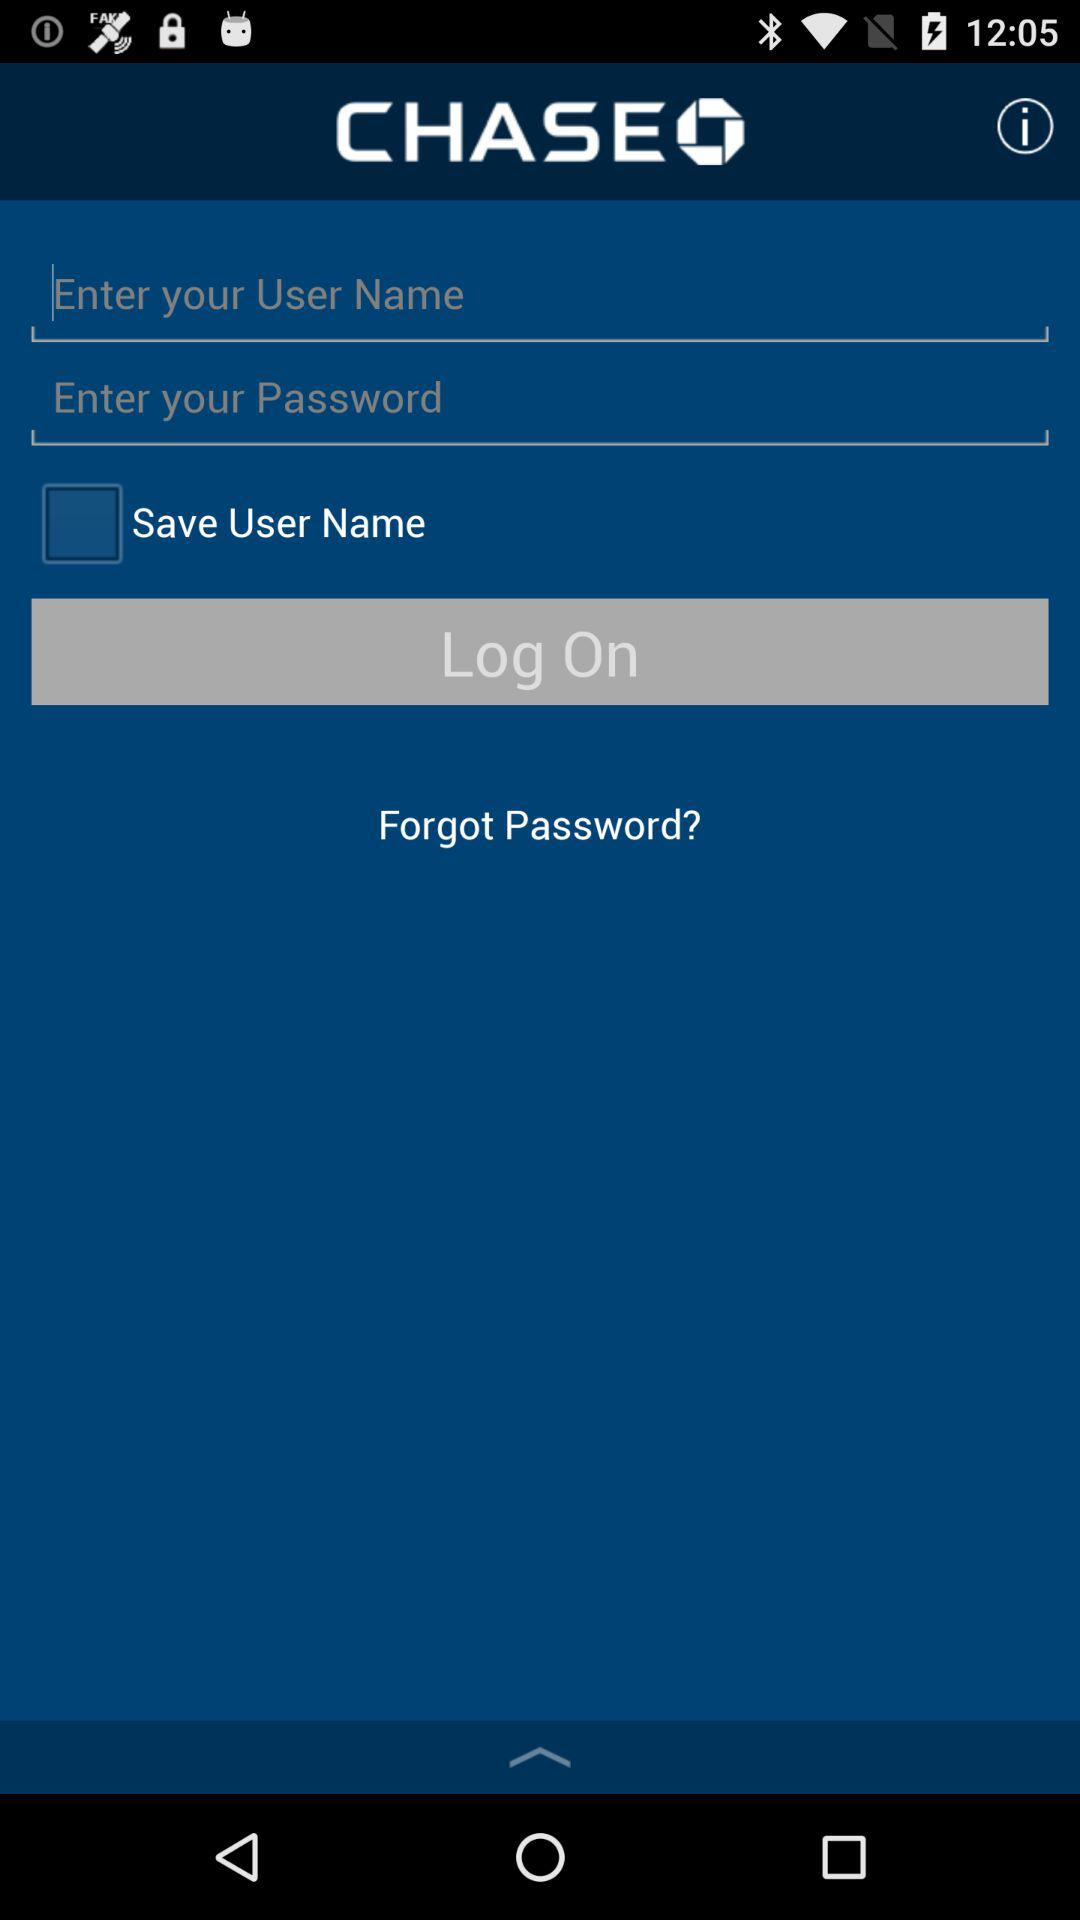What is the status of "Save User Name"? The status is "off". 